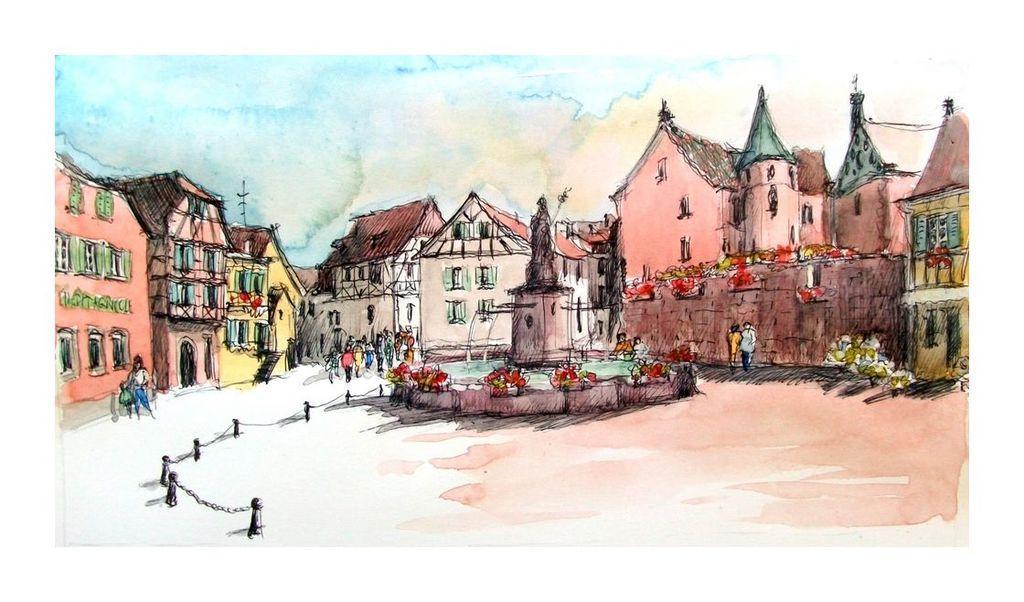Describe this image in one or two sentences. This is the painted image and in the foreground of this image, there is a sculpture, a fountain and a railing. In the background, there are buildings, few persons walking on the path, sky and the cloud. 